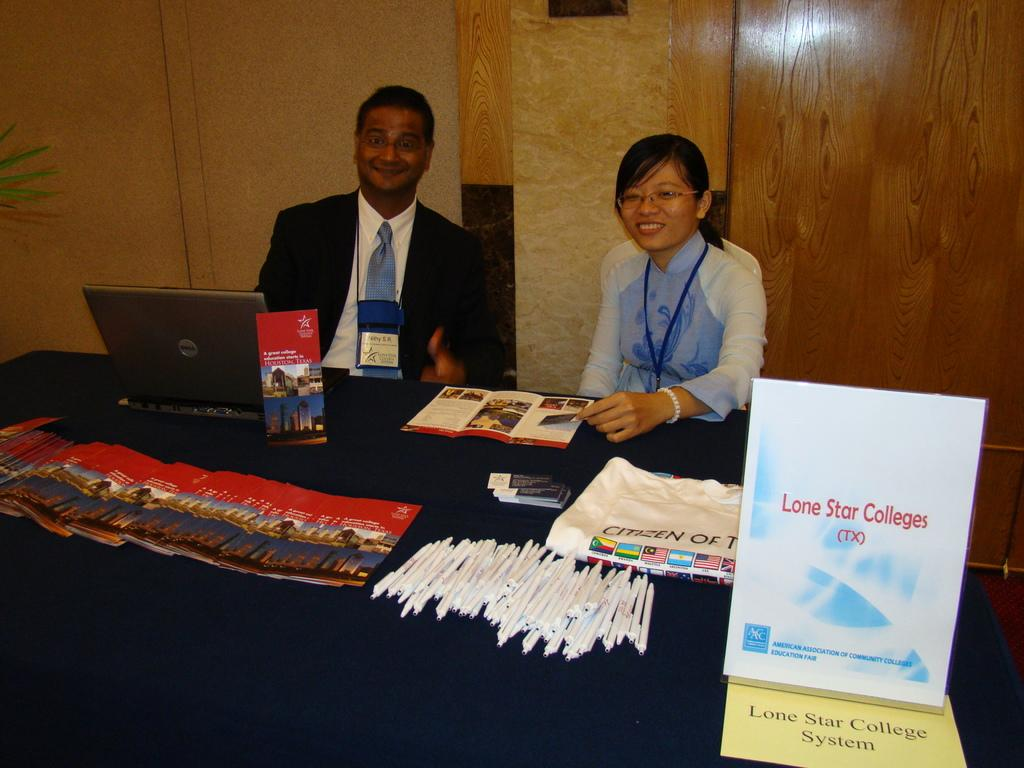Provide a one-sentence caption for the provided image. 2 people standing behind a table calle dlone star colleges. 